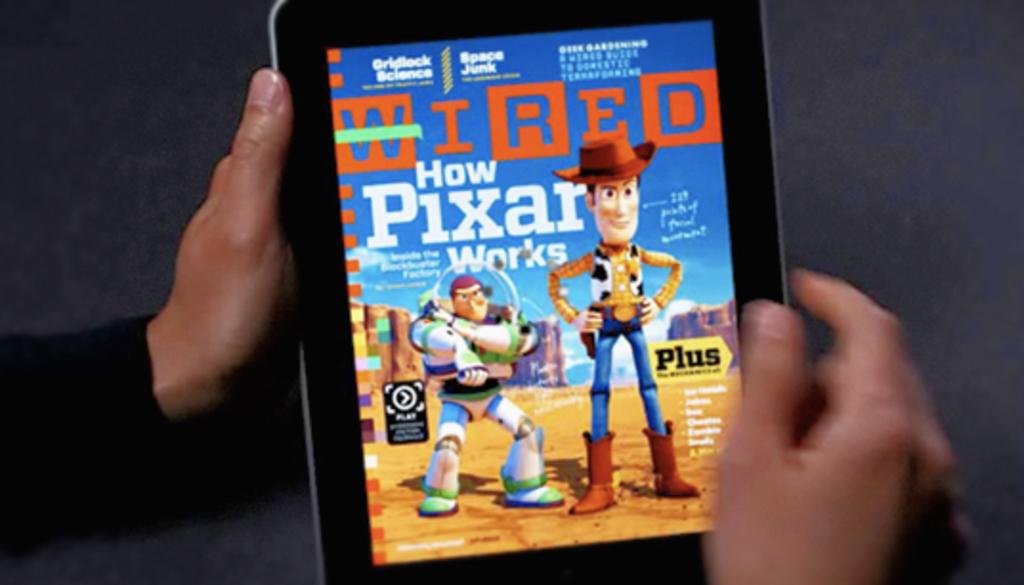What is the name of this magazine?
Give a very brief answer. Wired. What is the front page headline of the magazine?
Offer a very short reply. How pixar works. 